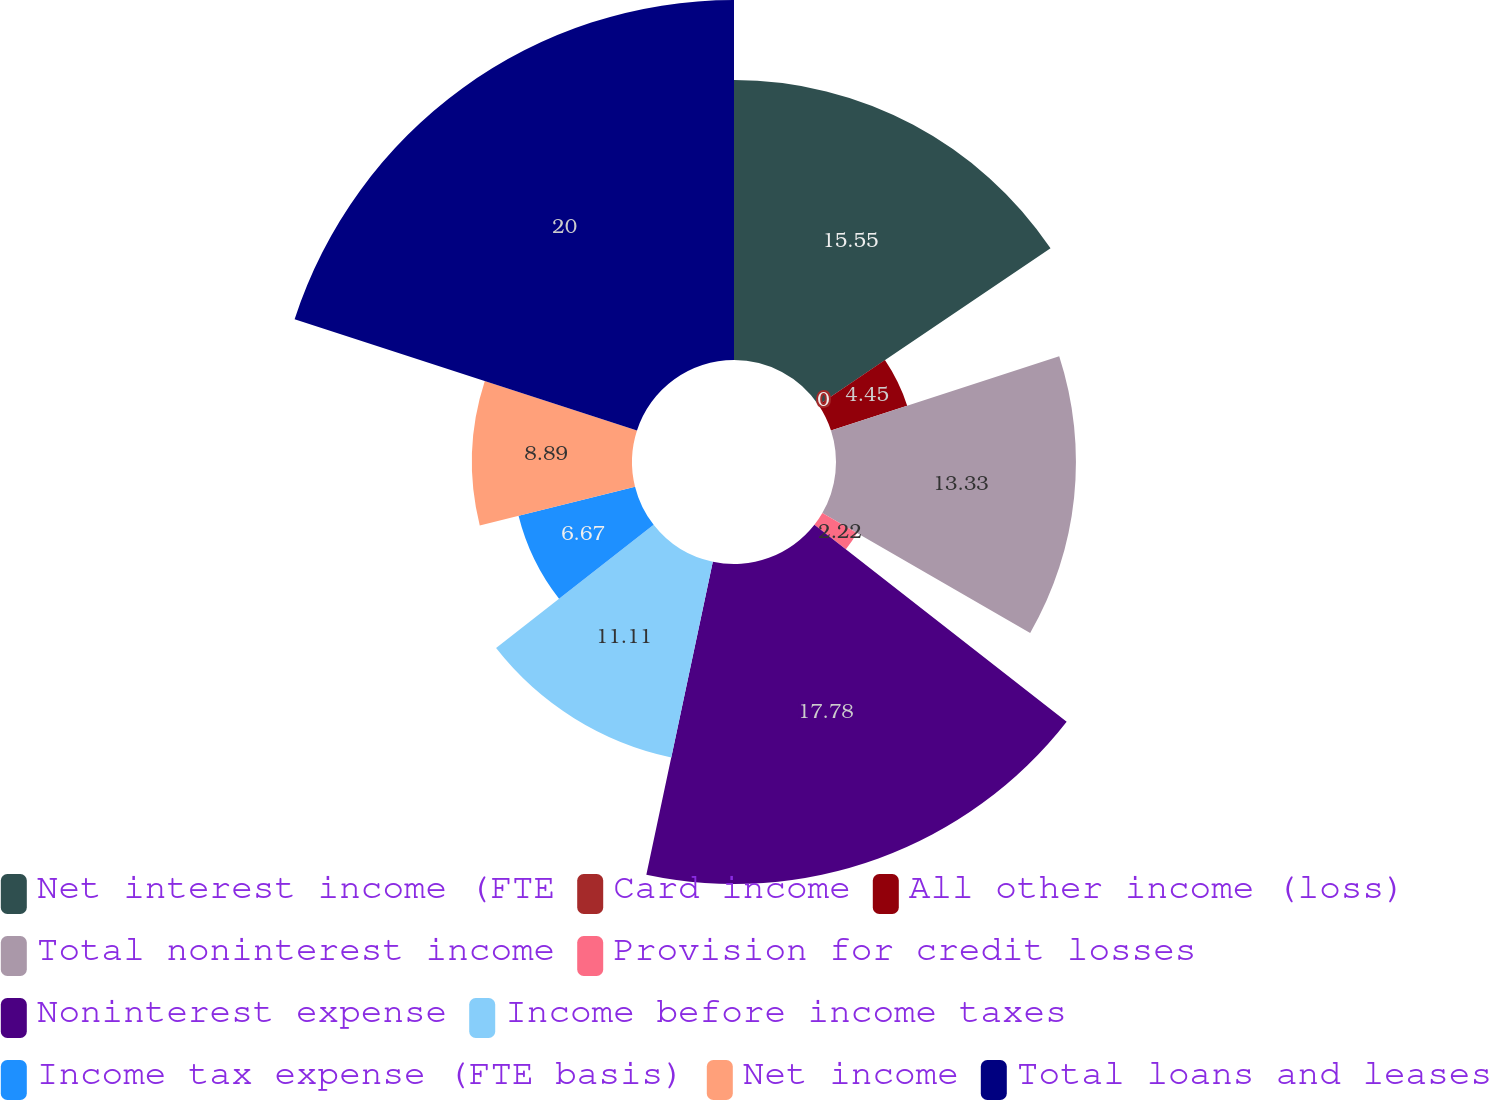Convert chart. <chart><loc_0><loc_0><loc_500><loc_500><pie_chart><fcel>Net interest income (FTE<fcel>Card income<fcel>All other income (loss)<fcel>Total noninterest income<fcel>Provision for credit losses<fcel>Noninterest expense<fcel>Income before income taxes<fcel>Income tax expense (FTE basis)<fcel>Net income<fcel>Total loans and leases<nl><fcel>15.55%<fcel>0.0%<fcel>4.45%<fcel>13.33%<fcel>2.22%<fcel>17.78%<fcel>11.11%<fcel>6.67%<fcel>8.89%<fcel>20.0%<nl></chart> 